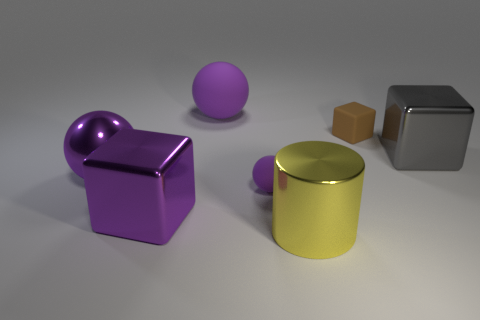The rubber thing that is both behind the tiny purple matte sphere and on the left side of the yellow metallic cylinder is what color?
Make the answer very short. Purple. There is a big block that is to the right of the big matte object; what number of large gray objects are to the right of it?
Make the answer very short. 0. What is the material of the small thing that is the same shape as the big purple rubber thing?
Provide a succinct answer. Rubber. The large cylinder is what color?
Give a very brief answer. Yellow. How many things are small purple things or purple metallic cylinders?
Make the answer very short. 1. What shape is the small matte object in front of the brown rubber block that is to the right of the cylinder?
Give a very brief answer. Sphere. How many other objects are the same material as the brown thing?
Give a very brief answer. 2. Is the big gray cube made of the same material as the big cube that is to the left of the big yellow cylinder?
Ensure brevity in your answer.  Yes. How many things are either gray metallic things behind the yellow metal thing or small objects in front of the tiny brown object?
Keep it short and to the point. 2. What number of other things are the same color as the large matte sphere?
Provide a short and direct response. 3. 